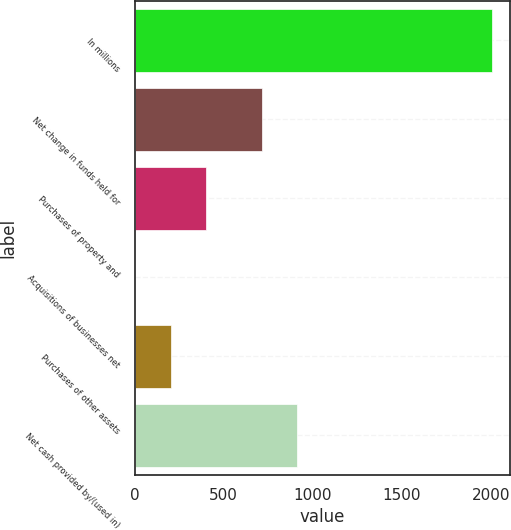Convert chart to OTSL. <chart><loc_0><loc_0><loc_500><loc_500><bar_chart><fcel>In millions<fcel>Net change in funds held for<fcel>Purchases of property and<fcel>Acquisitions of businesses net<fcel>Purchases of other assets<fcel>Net cash provided by/(used in)<nl><fcel>2007<fcel>713.4<fcel>403.88<fcel>3.1<fcel>203.49<fcel>913.79<nl></chart> 